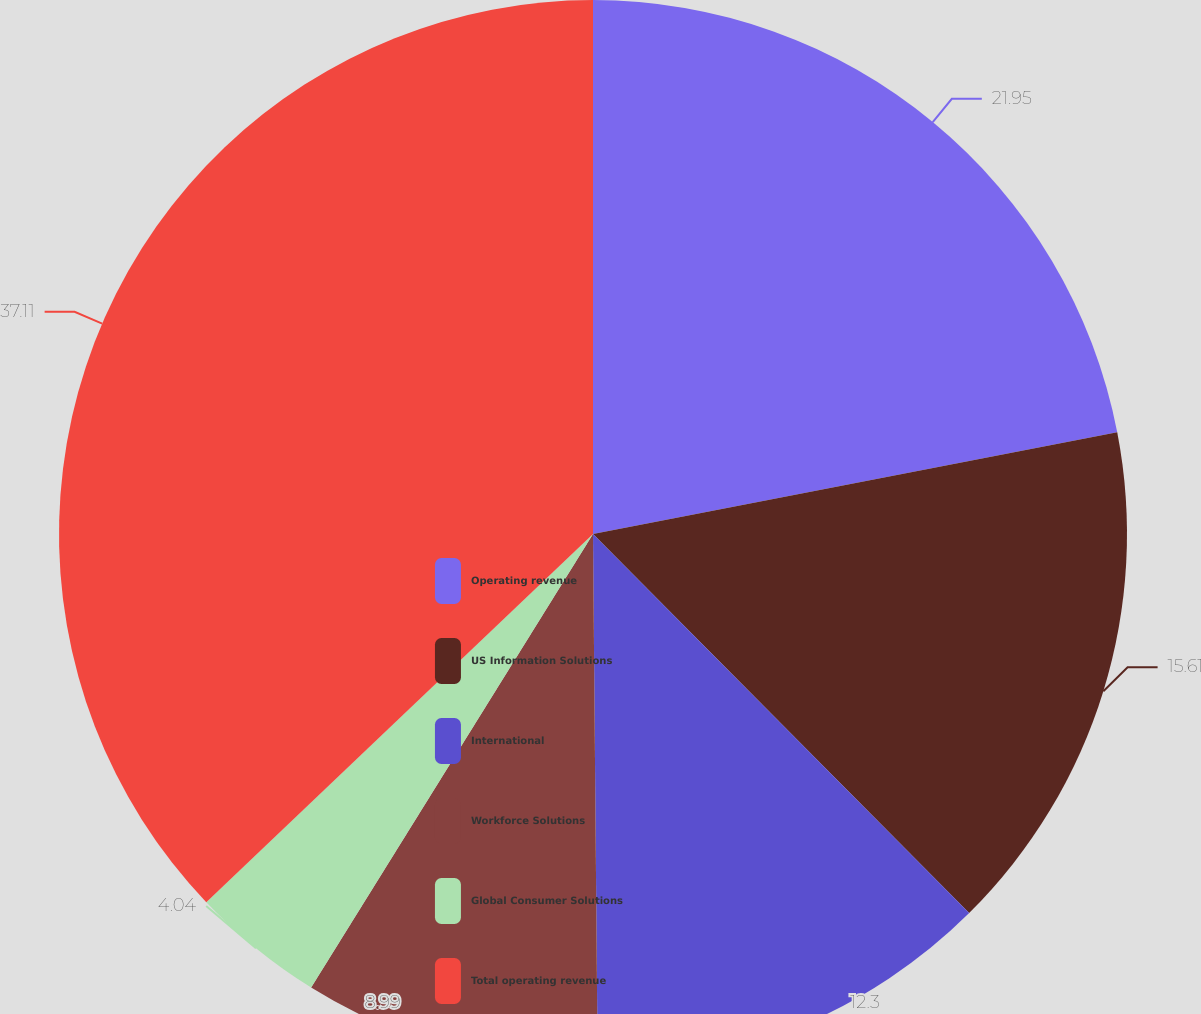Convert chart to OTSL. <chart><loc_0><loc_0><loc_500><loc_500><pie_chart><fcel>Operating revenue<fcel>US Information Solutions<fcel>International<fcel>Workforce Solutions<fcel>Global Consumer Solutions<fcel>Total operating revenue<nl><fcel>21.95%<fcel>15.61%<fcel>12.3%<fcel>8.99%<fcel>4.04%<fcel>37.11%<nl></chart> 